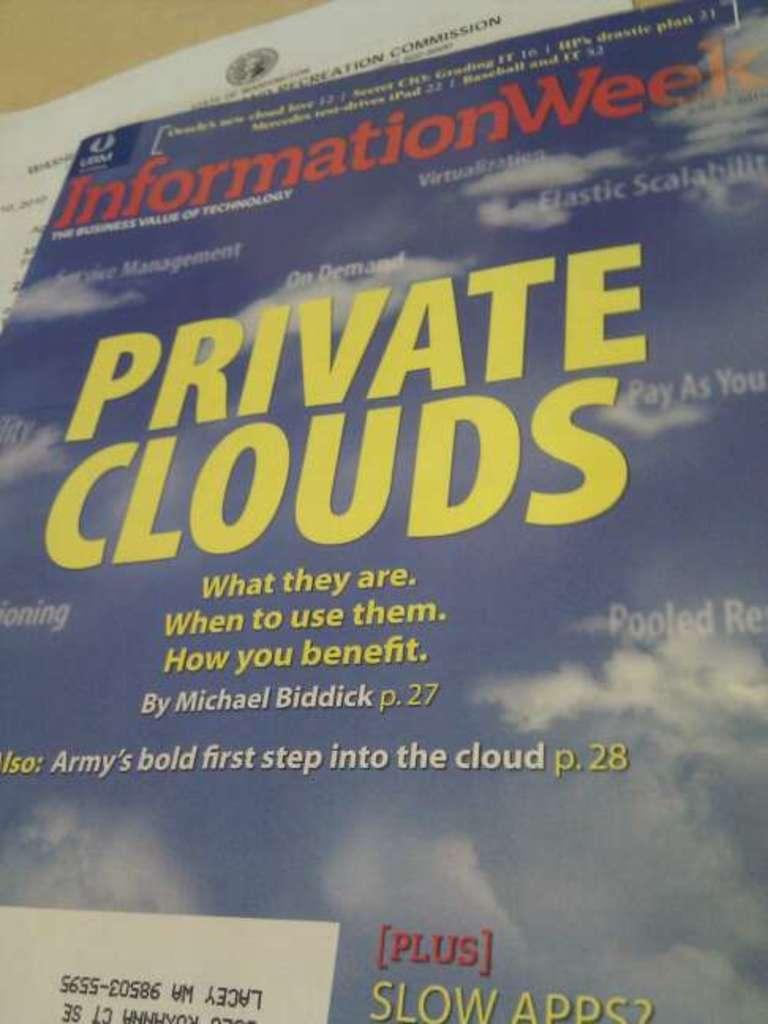<image>
Give a short and clear explanation of the subsequent image. a magazine with Private Clouds written on it 